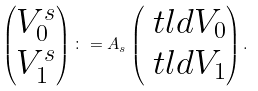Convert formula to latex. <formula><loc_0><loc_0><loc_500><loc_500>\begin{pmatrix} V _ { 0 } ^ { s } \\ V _ { 1 } ^ { s } \end{pmatrix} \colon = A _ { s } \begin{pmatrix} \ t l d V _ { 0 } \\ \ t l d V _ { 1 } \end{pmatrix} .</formula> 